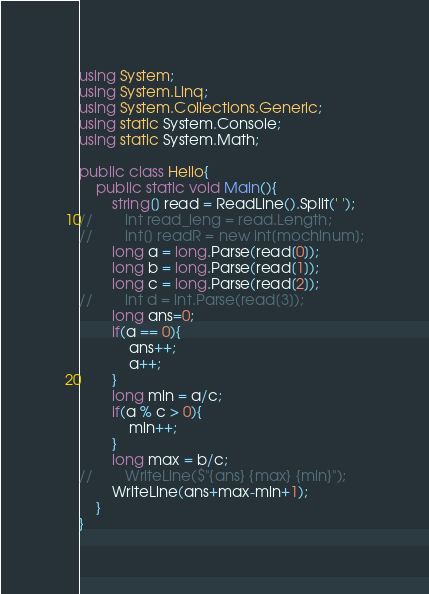Convert code to text. <code><loc_0><loc_0><loc_500><loc_500><_C#_>using System;
using System.Linq;
using System.Collections.Generic;
using static System.Console;
using static System.Math;
 
public class Hello{
    public static void Main(){
        string[] read = ReadLine().Split(' ');
//        int read_leng = read.Length;
//        int[] readR = new int[mochinum];
        long a = long.Parse(read[0]);
        long b = long.Parse(read[1]);
        long c = long.Parse(read[2]);
//        int d = int.Parse(read[3]);
        long ans=0;
        if(a == 0){
            ans++;
            a++;
        }
        long min = a/c;
        if(a % c > 0){
            min++;
        }
        long max = b/c;
//        WriteLine($"{ans} {max} {min}");
        WriteLine(ans+max-min+1);
    }
}
</code> 